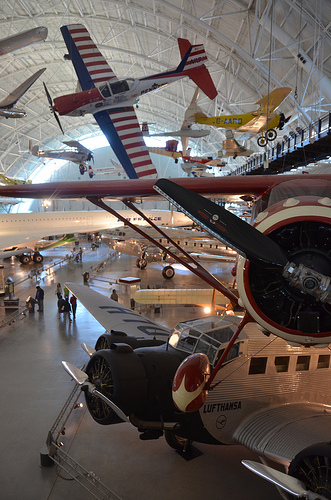<image>
Is there a airplane under the shed? Yes. The airplane is positioned underneath the shed, with the shed above it in the vertical space. 